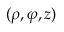<formula> <loc_0><loc_0><loc_500><loc_500>( \rho , \varphi , z )</formula> 